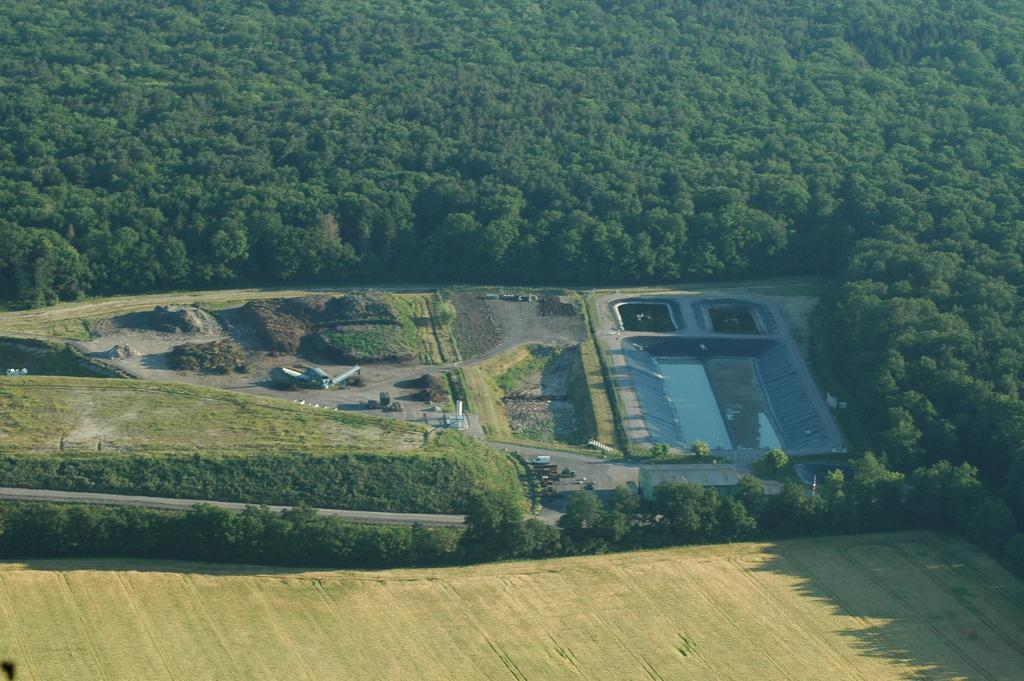What type of vegetation can be seen in the image? There are trees in the image. What else can be seen in the image besides trees? There are vehicles and grass visible in the image. Is there any water visible in the image? Yes, there is water visible in the image. What type of glue is being used to hold the trees together in the image? There is no glue present in the image, and the trees are not being held together. Can you see any children playing in the image? There is no indication of children playing in the image. 